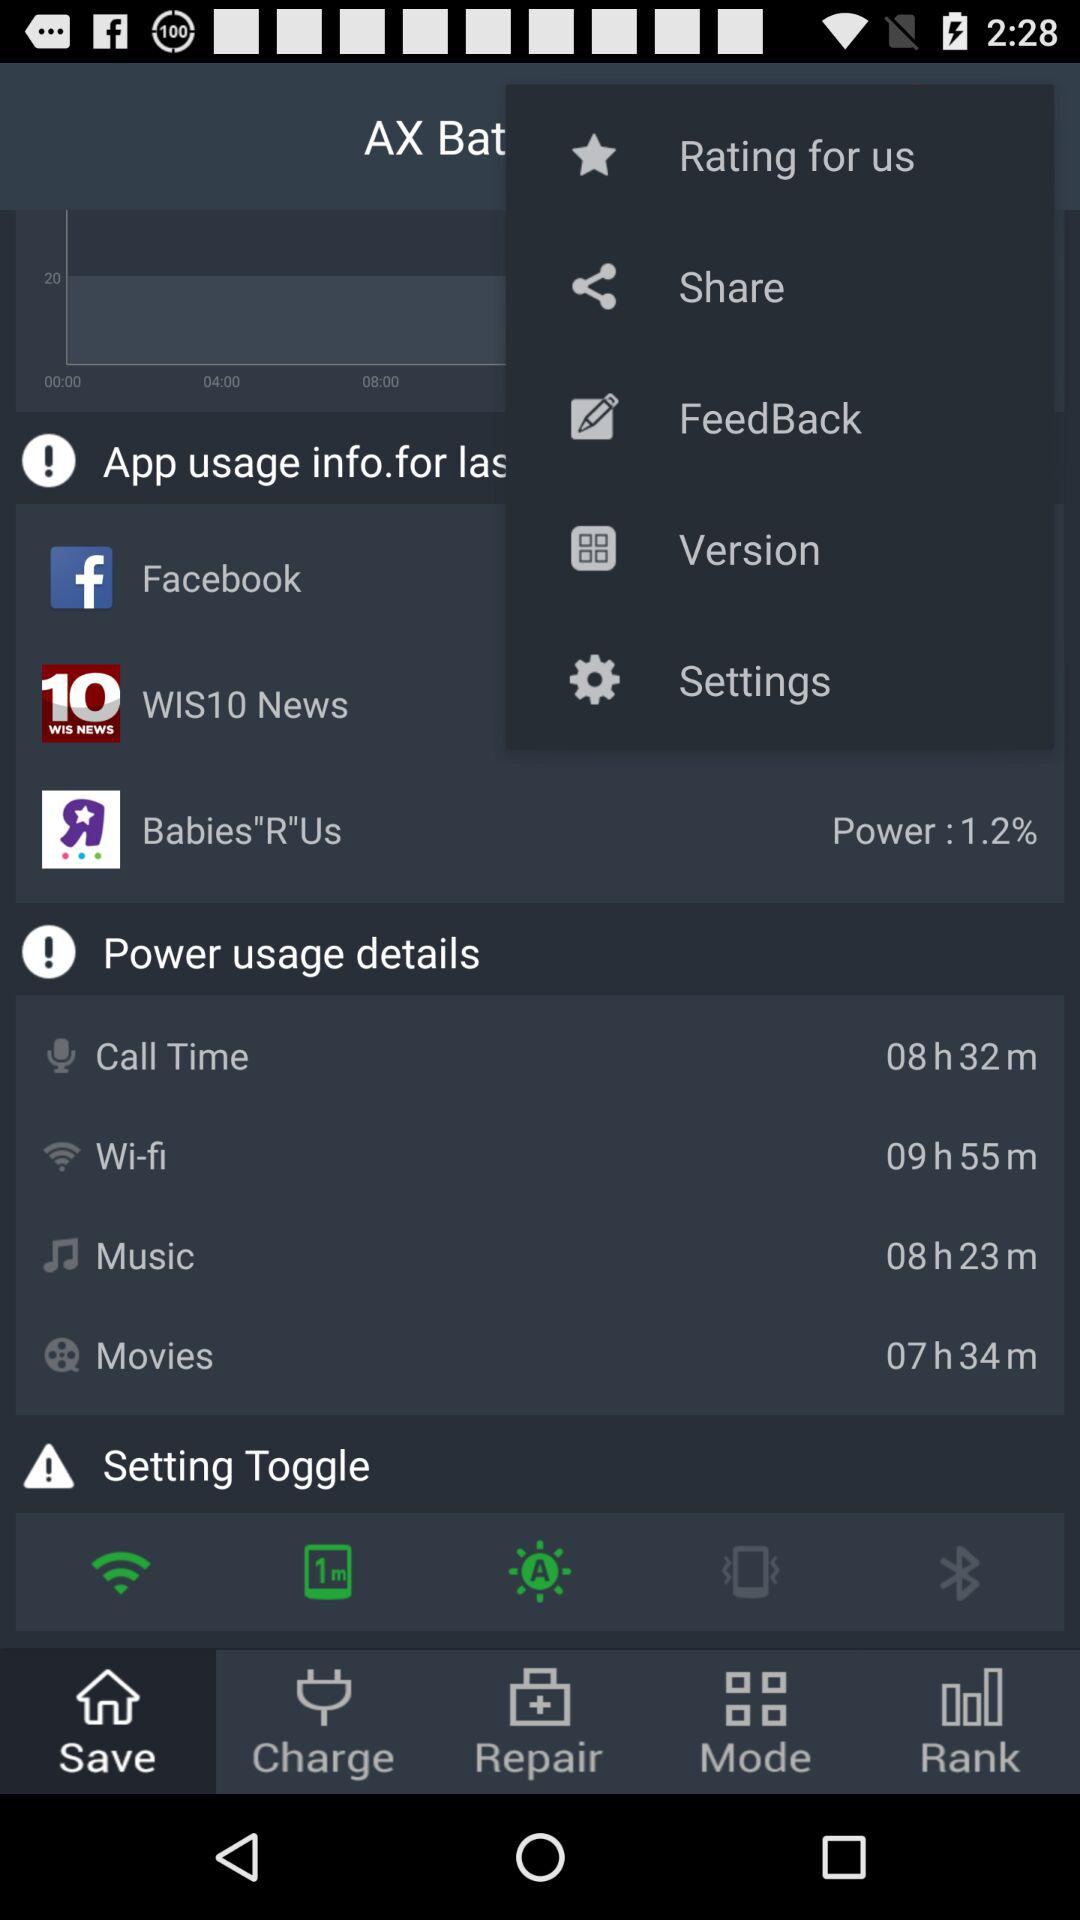How much time was consumed by the WiFi? The time that was consumed by the WiFi is 9 hours 55 minutes. 